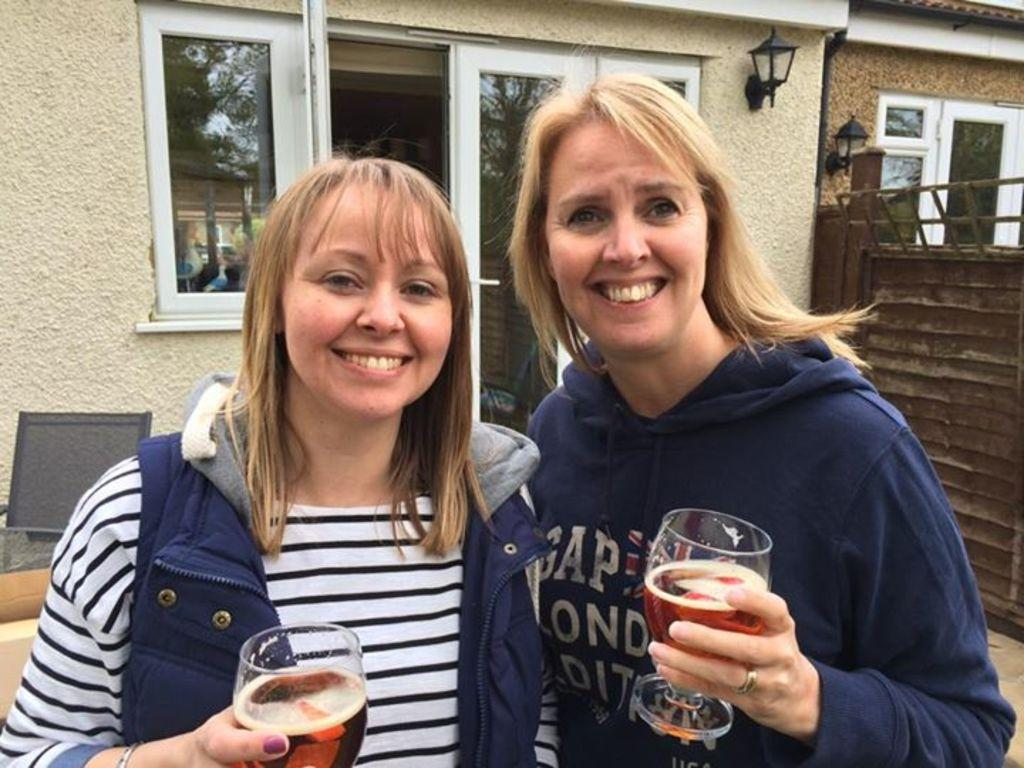How many women are present in the image? There are two women in the image. What are the women holding in the image? The women are holding beer glasses. What expression do the women have in the image? The women are smiling. What type of alley can be seen behind the women in the image? There is no alley visible in the image; it only features the two women holding beer glasses and smiling. What type of land is the image taken on? The type of land cannot be determined from the image, as it only shows the two women holding beer glasses and smiling. 